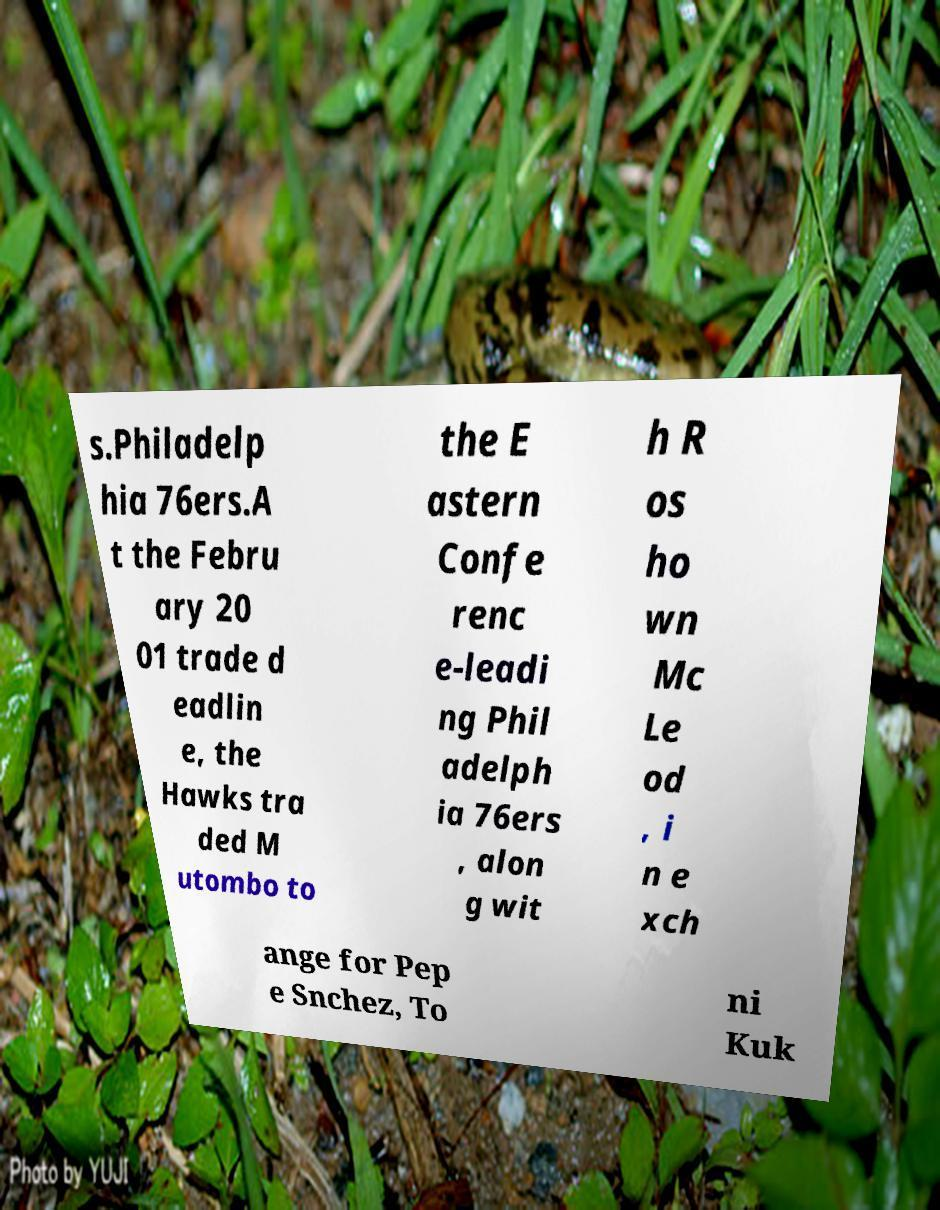Can you read and provide the text displayed in the image?This photo seems to have some interesting text. Can you extract and type it out for me? s.Philadelp hia 76ers.A t the Febru ary 20 01 trade d eadlin e, the Hawks tra ded M utombo to the E astern Confe renc e-leadi ng Phil adelph ia 76ers , alon g wit h R os ho wn Mc Le od , i n e xch ange for Pep e Snchez, To ni Kuk 